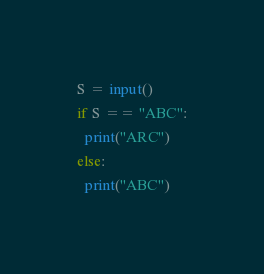Convert code to text. <code><loc_0><loc_0><loc_500><loc_500><_Python_>S = input()
if S == "ABC":
  print("ARC")
else:
  print("ABC")</code> 